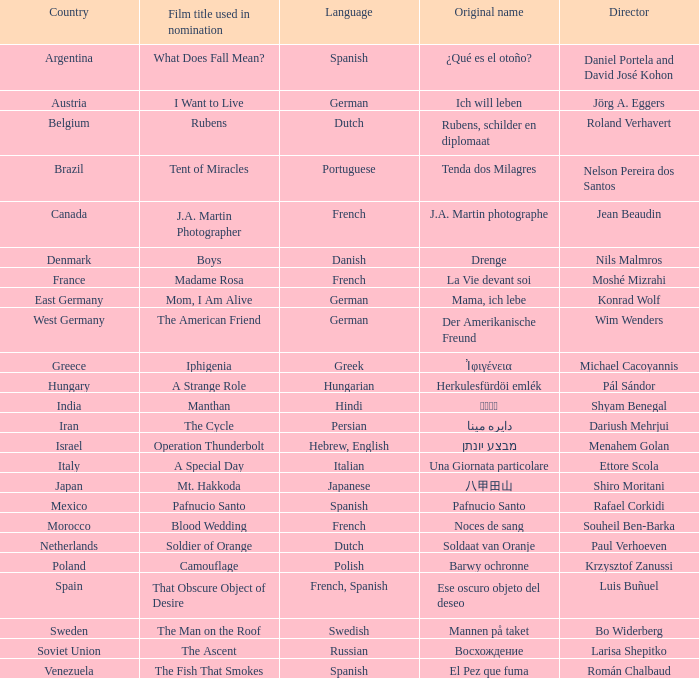Which country is the film Tent of Miracles from? Brazil. 